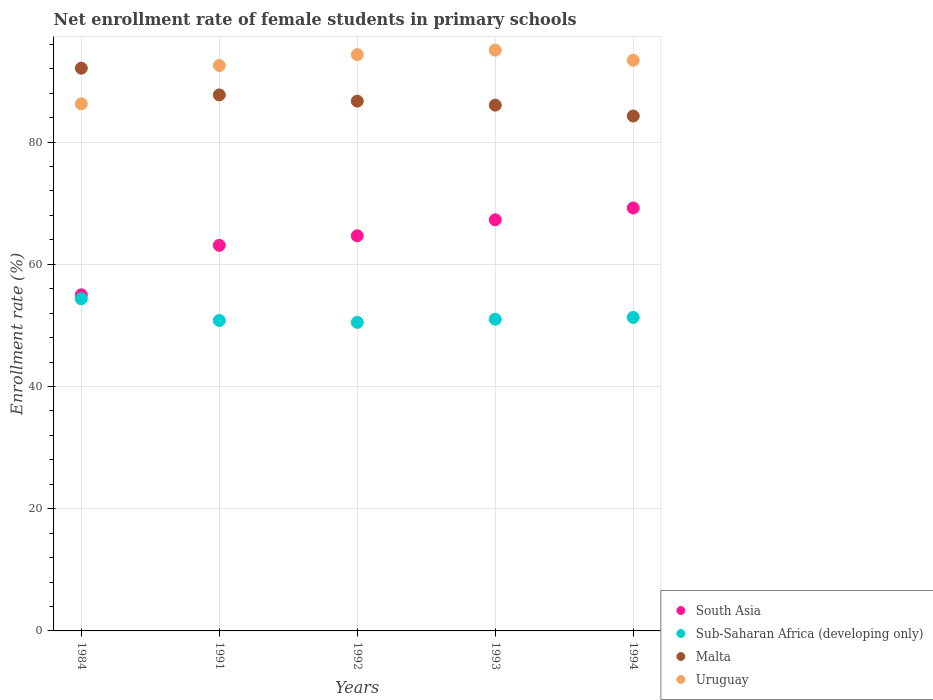Is the number of dotlines equal to the number of legend labels?
Make the answer very short. Yes. What is the net enrollment rate of female students in primary schools in South Asia in 1984?
Your answer should be compact. 55. Across all years, what is the maximum net enrollment rate of female students in primary schools in South Asia?
Offer a very short reply. 69.21. Across all years, what is the minimum net enrollment rate of female students in primary schools in Malta?
Your response must be concise. 84.26. In which year was the net enrollment rate of female students in primary schools in Malta maximum?
Make the answer very short. 1984. In which year was the net enrollment rate of female students in primary schools in South Asia minimum?
Your answer should be compact. 1984. What is the total net enrollment rate of female students in primary schools in Uruguay in the graph?
Provide a short and direct response. 461.5. What is the difference between the net enrollment rate of female students in primary schools in Sub-Saharan Africa (developing only) in 1992 and that in 1994?
Provide a succinct answer. -0.8. What is the difference between the net enrollment rate of female students in primary schools in South Asia in 1993 and the net enrollment rate of female students in primary schools in Uruguay in 1992?
Ensure brevity in your answer.  -27.03. What is the average net enrollment rate of female students in primary schools in Sub-Saharan Africa (developing only) per year?
Provide a short and direct response. 51.59. In the year 1991, what is the difference between the net enrollment rate of female students in primary schools in Malta and net enrollment rate of female students in primary schools in Sub-Saharan Africa (developing only)?
Your answer should be very brief. 36.91. In how many years, is the net enrollment rate of female students in primary schools in Malta greater than 56 %?
Your answer should be very brief. 5. What is the ratio of the net enrollment rate of female students in primary schools in Malta in 1984 to that in 1991?
Your answer should be compact. 1.05. What is the difference between the highest and the second highest net enrollment rate of female students in primary schools in South Asia?
Give a very brief answer. 1.93. What is the difference between the highest and the lowest net enrollment rate of female students in primary schools in Sub-Saharan Africa (developing only)?
Make the answer very short. 3.86. How many dotlines are there?
Ensure brevity in your answer.  4. What is the difference between two consecutive major ticks on the Y-axis?
Make the answer very short. 20. Are the values on the major ticks of Y-axis written in scientific E-notation?
Your response must be concise. No. Does the graph contain any zero values?
Offer a terse response. No. Does the graph contain grids?
Ensure brevity in your answer.  Yes. How many legend labels are there?
Keep it short and to the point. 4. What is the title of the graph?
Ensure brevity in your answer.  Net enrollment rate of female students in primary schools. What is the label or title of the X-axis?
Offer a terse response. Years. What is the label or title of the Y-axis?
Provide a short and direct response. Enrollment rate (%). What is the Enrollment rate (%) in South Asia in 1984?
Make the answer very short. 55. What is the Enrollment rate (%) in Sub-Saharan Africa (developing only) in 1984?
Provide a short and direct response. 54.36. What is the Enrollment rate (%) of Malta in 1984?
Provide a succinct answer. 92.09. What is the Enrollment rate (%) in Uruguay in 1984?
Ensure brevity in your answer.  86.25. What is the Enrollment rate (%) in South Asia in 1991?
Keep it short and to the point. 63.1. What is the Enrollment rate (%) in Sub-Saharan Africa (developing only) in 1991?
Offer a very short reply. 50.8. What is the Enrollment rate (%) in Malta in 1991?
Offer a terse response. 87.71. What is the Enrollment rate (%) of Uruguay in 1991?
Your answer should be very brief. 92.53. What is the Enrollment rate (%) in South Asia in 1992?
Offer a very short reply. 64.66. What is the Enrollment rate (%) of Sub-Saharan Africa (developing only) in 1992?
Provide a succinct answer. 50.5. What is the Enrollment rate (%) of Malta in 1992?
Ensure brevity in your answer.  86.7. What is the Enrollment rate (%) in Uruguay in 1992?
Your response must be concise. 94.31. What is the Enrollment rate (%) in South Asia in 1993?
Your response must be concise. 67.28. What is the Enrollment rate (%) of Sub-Saharan Africa (developing only) in 1993?
Give a very brief answer. 51.01. What is the Enrollment rate (%) of Malta in 1993?
Provide a short and direct response. 86.04. What is the Enrollment rate (%) of Uruguay in 1993?
Give a very brief answer. 95.03. What is the Enrollment rate (%) of South Asia in 1994?
Provide a short and direct response. 69.21. What is the Enrollment rate (%) in Sub-Saharan Africa (developing only) in 1994?
Ensure brevity in your answer.  51.3. What is the Enrollment rate (%) in Malta in 1994?
Provide a succinct answer. 84.26. What is the Enrollment rate (%) in Uruguay in 1994?
Give a very brief answer. 93.38. Across all years, what is the maximum Enrollment rate (%) in South Asia?
Your answer should be compact. 69.21. Across all years, what is the maximum Enrollment rate (%) in Sub-Saharan Africa (developing only)?
Your answer should be compact. 54.36. Across all years, what is the maximum Enrollment rate (%) in Malta?
Your response must be concise. 92.09. Across all years, what is the maximum Enrollment rate (%) in Uruguay?
Your answer should be compact. 95.03. Across all years, what is the minimum Enrollment rate (%) in South Asia?
Offer a terse response. 55. Across all years, what is the minimum Enrollment rate (%) of Sub-Saharan Africa (developing only)?
Offer a terse response. 50.5. Across all years, what is the minimum Enrollment rate (%) of Malta?
Offer a very short reply. 84.26. Across all years, what is the minimum Enrollment rate (%) in Uruguay?
Your response must be concise. 86.25. What is the total Enrollment rate (%) of South Asia in the graph?
Provide a short and direct response. 319.26. What is the total Enrollment rate (%) of Sub-Saharan Africa (developing only) in the graph?
Give a very brief answer. 257.96. What is the total Enrollment rate (%) of Malta in the graph?
Make the answer very short. 436.8. What is the total Enrollment rate (%) in Uruguay in the graph?
Ensure brevity in your answer.  461.5. What is the difference between the Enrollment rate (%) of South Asia in 1984 and that in 1991?
Your response must be concise. -8.09. What is the difference between the Enrollment rate (%) in Sub-Saharan Africa (developing only) in 1984 and that in 1991?
Make the answer very short. 3.55. What is the difference between the Enrollment rate (%) of Malta in 1984 and that in 1991?
Give a very brief answer. 4.38. What is the difference between the Enrollment rate (%) of Uruguay in 1984 and that in 1991?
Provide a short and direct response. -6.27. What is the difference between the Enrollment rate (%) of South Asia in 1984 and that in 1992?
Your answer should be compact. -9.66. What is the difference between the Enrollment rate (%) in Sub-Saharan Africa (developing only) in 1984 and that in 1992?
Your answer should be very brief. 3.86. What is the difference between the Enrollment rate (%) in Malta in 1984 and that in 1992?
Ensure brevity in your answer.  5.39. What is the difference between the Enrollment rate (%) of Uruguay in 1984 and that in 1992?
Offer a very short reply. -8.05. What is the difference between the Enrollment rate (%) in South Asia in 1984 and that in 1993?
Give a very brief answer. -12.28. What is the difference between the Enrollment rate (%) in Sub-Saharan Africa (developing only) in 1984 and that in 1993?
Ensure brevity in your answer.  3.35. What is the difference between the Enrollment rate (%) of Malta in 1984 and that in 1993?
Keep it short and to the point. 6.05. What is the difference between the Enrollment rate (%) of Uruguay in 1984 and that in 1993?
Ensure brevity in your answer.  -8.78. What is the difference between the Enrollment rate (%) in South Asia in 1984 and that in 1994?
Give a very brief answer. -14.21. What is the difference between the Enrollment rate (%) of Sub-Saharan Africa (developing only) in 1984 and that in 1994?
Offer a very short reply. 3.06. What is the difference between the Enrollment rate (%) in Malta in 1984 and that in 1994?
Give a very brief answer. 7.83. What is the difference between the Enrollment rate (%) of Uruguay in 1984 and that in 1994?
Your answer should be very brief. -7.12. What is the difference between the Enrollment rate (%) of South Asia in 1991 and that in 1992?
Provide a short and direct response. -1.57. What is the difference between the Enrollment rate (%) in Sub-Saharan Africa (developing only) in 1991 and that in 1992?
Provide a short and direct response. 0.31. What is the difference between the Enrollment rate (%) of Malta in 1991 and that in 1992?
Offer a very short reply. 1.02. What is the difference between the Enrollment rate (%) of Uruguay in 1991 and that in 1992?
Give a very brief answer. -1.78. What is the difference between the Enrollment rate (%) of South Asia in 1991 and that in 1993?
Offer a very short reply. -4.18. What is the difference between the Enrollment rate (%) of Sub-Saharan Africa (developing only) in 1991 and that in 1993?
Ensure brevity in your answer.  -0.2. What is the difference between the Enrollment rate (%) in Malta in 1991 and that in 1993?
Give a very brief answer. 1.67. What is the difference between the Enrollment rate (%) of Uruguay in 1991 and that in 1993?
Provide a short and direct response. -2.51. What is the difference between the Enrollment rate (%) in South Asia in 1991 and that in 1994?
Your answer should be compact. -6.12. What is the difference between the Enrollment rate (%) of Sub-Saharan Africa (developing only) in 1991 and that in 1994?
Your answer should be very brief. -0.49. What is the difference between the Enrollment rate (%) of Malta in 1991 and that in 1994?
Your response must be concise. 3.45. What is the difference between the Enrollment rate (%) in Uruguay in 1991 and that in 1994?
Keep it short and to the point. -0.85. What is the difference between the Enrollment rate (%) of South Asia in 1992 and that in 1993?
Provide a succinct answer. -2.62. What is the difference between the Enrollment rate (%) in Sub-Saharan Africa (developing only) in 1992 and that in 1993?
Offer a terse response. -0.51. What is the difference between the Enrollment rate (%) in Malta in 1992 and that in 1993?
Your answer should be very brief. 0.66. What is the difference between the Enrollment rate (%) of Uruguay in 1992 and that in 1993?
Offer a very short reply. -0.73. What is the difference between the Enrollment rate (%) in South Asia in 1992 and that in 1994?
Make the answer very short. -4.55. What is the difference between the Enrollment rate (%) in Sub-Saharan Africa (developing only) in 1992 and that in 1994?
Ensure brevity in your answer.  -0.8. What is the difference between the Enrollment rate (%) of Malta in 1992 and that in 1994?
Make the answer very short. 2.44. What is the difference between the Enrollment rate (%) in Uruguay in 1992 and that in 1994?
Ensure brevity in your answer.  0.93. What is the difference between the Enrollment rate (%) in South Asia in 1993 and that in 1994?
Offer a terse response. -1.93. What is the difference between the Enrollment rate (%) in Sub-Saharan Africa (developing only) in 1993 and that in 1994?
Keep it short and to the point. -0.29. What is the difference between the Enrollment rate (%) in Malta in 1993 and that in 1994?
Ensure brevity in your answer.  1.78. What is the difference between the Enrollment rate (%) in Uruguay in 1993 and that in 1994?
Your answer should be compact. 1.66. What is the difference between the Enrollment rate (%) in South Asia in 1984 and the Enrollment rate (%) in Sub-Saharan Africa (developing only) in 1991?
Your response must be concise. 4.2. What is the difference between the Enrollment rate (%) of South Asia in 1984 and the Enrollment rate (%) of Malta in 1991?
Your response must be concise. -32.71. What is the difference between the Enrollment rate (%) in South Asia in 1984 and the Enrollment rate (%) in Uruguay in 1991?
Make the answer very short. -37.52. What is the difference between the Enrollment rate (%) in Sub-Saharan Africa (developing only) in 1984 and the Enrollment rate (%) in Malta in 1991?
Your response must be concise. -33.36. What is the difference between the Enrollment rate (%) of Sub-Saharan Africa (developing only) in 1984 and the Enrollment rate (%) of Uruguay in 1991?
Your response must be concise. -38.17. What is the difference between the Enrollment rate (%) of Malta in 1984 and the Enrollment rate (%) of Uruguay in 1991?
Provide a short and direct response. -0.44. What is the difference between the Enrollment rate (%) in South Asia in 1984 and the Enrollment rate (%) in Sub-Saharan Africa (developing only) in 1992?
Provide a short and direct response. 4.51. What is the difference between the Enrollment rate (%) in South Asia in 1984 and the Enrollment rate (%) in Malta in 1992?
Provide a succinct answer. -31.69. What is the difference between the Enrollment rate (%) in South Asia in 1984 and the Enrollment rate (%) in Uruguay in 1992?
Offer a very short reply. -39.3. What is the difference between the Enrollment rate (%) of Sub-Saharan Africa (developing only) in 1984 and the Enrollment rate (%) of Malta in 1992?
Make the answer very short. -32.34. What is the difference between the Enrollment rate (%) in Sub-Saharan Africa (developing only) in 1984 and the Enrollment rate (%) in Uruguay in 1992?
Ensure brevity in your answer.  -39.95. What is the difference between the Enrollment rate (%) in Malta in 1984 and the Enrollment rate (%) in Uruguay in 1992?
Make the answer very short. -2.22. What is the difference between the Enrollment rate (%) in South Asia in 1984 and the Enrollment rate (%) in Sub-Saharan Africa (developing only) in 1993?
Your answer should be very brief. 4. What is the difference between the Enrollment rate (%) of South Asia in 1984 and the Enrollment rate (%) of Malta in 1993?
Offer a very short reply. -31.04. What is the difference between the Enrollment rate (%) of South Asia in 1984 and the Enrollment rate (%) of Uruguay in 1993?
Your answer should be very brief. -40.03. What is the difference between the Enrollment rate (%) in Sub-Saharan Africa (developing only) in 1984 and the Enrollment rate (%) in Malta in 1993?
Your answer should be compact. -31.69. What is the difference between the Enrollment rate (%) in Sub-Saharan Africa (developing only) in 1984 and the Enrollment rate (%) in Uruguay in 1993?
Give a very brief answer. -40.68. What is the difference between the Enrollment rate (%) in Malta in 1984 and the Enrollment rate (%) in Uruguay in 1993?
Make the answer very short. -2.94. What is the difference between the Enrollment rate (%) in South Asia in 1984 and the Enrollment rate (%) in Sub-Saharan Africa (developing only) in 1994?
Provide a succinct answer. 3.7. What is the difference between the Enrollment rate (%) of South Asia in 1984 and the Enrollment rate (%) of Malta in 1994?
Offer a very short reply. -29.26. What is the difference between the Enrollment rate (%) of South Asia in 1984 and the Enrollment rate (%) of Uruguay in 1994?
Ensure brevity in your answer.  -38.37. What is the difference between the Enrollment rate (%) of Sub-Saharan Africa (developing only) in 1984 and the Enrollment rate (%) of Malta in 1994?
Keep it short and to the point. -29.9. What is the difference between the Enrollment rate (%) in Sub-Saharan Africa (developing only) in 1984 and the Enrollment rate (%) in Uruguay in 1994?
Provide a succinct answer. -39.02. What is the difference between the Enrollment rate (%) in Malta in 1984 and the Enrollment rate (%) in Uruguay in 1994?
Provide a short and direct response. -1.29. What is the difference between the Enrollment rate (%) in South Asia in 1991 and the Enrollment rate (%) in Sub-Saharan Africa (developing only) in 1992?
Provide a succinct answer. 12.6. What is the difference between the Enrollment rate (%) of South Asia in 1991 and the Enrollment rate (%) of Malta in 1992?
Offer a very short reply. -23.6. What is the difference between the Enrollment rate (%) of South Asia in 1991 and the Enrollment rate (%) of Uruguay in 1992?
Provide a short and direct response. -31.21. What is the difference between the Enrollment rate (%) of Sub-Saharan Africa (developing only) in 1991 and the Enrollment rate (%) of Malta in 1992?
Offer a very short reply. -35.89. What is the difference between the Enrollment rate (%) in Sub-Saharan Africa (developing only) in 1991 and the Enrollment rate (%) in Uruguay in 1992?
Keep it short and to the point. -43.5. What is the difference between the Enrollment rate (%) of Malta in 1991 and the Enrollment rate (%) of Uruguay in 1992?
Your answer should be compact. -6.6. What is the difference between the Enrollment rate (%) in South Asia in 1991 and the Enrollment rate (%) in Sub-Saharan Africa (developing only) in 1993?
Make the answer very short. 12.09. What is the difference between the Enrollment rate (%) of South Asia in 1991 and the Enrollment rate (%) of Malta in 1993?
Provide a short and direct response. -22.94. What is the difference between the Enrollment rate (%) in South Asia in 1991 and the Enrollment rate (%) in Uruguay in 1993?
Your answer should be compact. -31.94. What is the difference between the Enrollment rate (%) of Sub-Saharan Africa (developing only) in 1991 and the Enrollment rate (%) of Malta in 1993?
Provide a succinct answer. -35.24. What is the difference between the Enrollment rate (%) of Sub-Saharan Africa (developing only) in 1991 and the Enrollment rate (%) of Uruguay in 1993?
Your answer should be very brief. -44.23. What is the difference between the Enrollment rate (%) of Malta in 1991 and the Enrollment rate (%) of Uruguay in 1993?
Your answer should be very brief. -7.32. What is the difference between the Enrollment rate (%) of South Asia in 1991 and the Enrollment rate (%) of Sub-Saharan Africa (developing only) in 1994?
Provide a short and direct response. 11.8. What is the difference between the Enrollment rate (%) of South Asia in 1991 and the Enrollment rate (%) of Malta in 1994?
Your response must be concise. -21.16. What is the difference between the Enrollment rate (%) of South Asia in 1991 and the Enrollment rate (%) of Uruguay in 1994?
Your answer should be very brief. -30.28. What is the difference between the Enrollment rate (%) in Sub-Saharan Africa (developing only) in 1991 and the Enrollment rate (%) in Malta in 1994?
Keep it short and to the point. -33.46. What is the difference between the Enrollment rate (%) of Sub-Saharan Africa (developing only) in 1991 and the Enrollment rate (%) of Uruguay in 1994?
Keep it short and to the point. -42.57. What is the difference between the Enrollment rate (%) in Malta in 1991 and the Enrollment rate (%) in Uruguay in 1994?
Keep it short and to the point. -5.67. What is the difference between the Enrollment rate (%) of South Asia in 1992 and the Enrollment rate (%) of Sub-Saharan Africa (developing only) in 1993?
Your answer should be very brief. 13.66. What is the difference between the Enrollment rate (%) in South Asia in 1992 and the Enrollment rate (%) in Malta in 1993?
Offer a very short reply. -21.38. What is the difference between the Enrollment rate (%) in South Asia in 1992 and the Enrollment rate (%) in Uruguay in 1993?
Offer a very short reply. -30.37. What is the difference between the Enrollment rate (%) of Sub-Saharan Africa (developing only) in 1992 and the Enrollment rate (%) of Malta in 1993?
Your response must be concise. -35.55. What is the difference between the Enrollment rate (%) of Sub-Saharan Africa (developing only) in 1992 and the Enrollment rate (%) of Uruguay in 1993?
Your answer should be compact. -44.54. What is the difference between the Enrollment rate (%) in Malta in 1992 and the Enrollment rate (%) in Uruguay in 1993?
Keep it short and to the point. -8.34. What is the difference between the Enrollment rate (%) in South Asia in 1992 and the Enrollment rate (%) in Sub-Saharan Africa (developing only) in 1994?
Make the answer very short. 13.36. What is the difference between the Enrollment rate (%) in South Asia in 1992 and the Enrollment rate (%) in Malta in 1994?
Offer a very short reply. -19.6. What is the difference between the Enrollment rate (%) in South Asia in 1992 and the Enrollment rate (%) in Uruguay in 1994?
Offer a very short reply. -28.71. What is the difference between the Enrollment rate (%) in Sub-Saharan Africa (developing only) in 1992 and the Enrollment rate (%) in Malta in 1994?
Your answer should be compact. -33.76. What is the difference between the Enrollment rate (%) in Sub-Saharan Africa (developing only) in 1992 and the Enrollment rate (%) in Uruguay in 1994?
Provide a short and direct response. -42.88. What is the difference between the Enrollment rate (%) in Malta in 1992 and the Enrollment rate (%) in Uruguay in 1994?
Make the answer very short. -6.68. What is the difference between the Enrollment rate (%) of South Asia in 1993 and the Enrollment rate (%) of Sub-Saharan Africa (developing only) in 1994?
Your answer should be very brief. 15.98. What is the difference between the Enrollment rate (%) of South Asia in 1993 and the Enrollment rate (%) of Malta in 1994?
Offer a terse response. -16.98. What is the difference between the Enrollment rate (%) in South Asia in 1993 and the Enrollment rate (%) in Uruguay in 1994?
Give a very brief answer. -26.1. What is the difference between the Enrollment rate (%) of Sub-Saharan Africa (developing only) in 1993 and the Enrollment rate (%) of Malta in 1994?
Offer a very short reply. -33.25. What is the difference between the Enrollment rate (%) of Sub-Saharan Africa (developing only) in 1993 and the Enrollment rate (%) of Uruguay in 1994?
Offer a very short reply. -42.37. What is the difference between the Enrollment rate (%) in Malta in 1993 and the Enrollment rate (%) in Uruguay in 1994?
Give a very brief answer. -7.34. What is the average Enrollment rate (%) in South Asia per year?
Provide a short and direct response. 63.85. What is the average Enrollment rate (%) of Sub-Saharan Africa (developing only) per year?
Offer a very short reply. 51.59. What is the average Enrollment rate (%) of Malta per year?
Offer a very short reply. 87.36. What is the average Enrollment rate (%) of Uruguay per year?
Provide a short and direct response. 92.3. In the year 1984, what is the difference between the Enrollment rate (%) in South Asia and Enrollment rate (%) in Sub-Saharan Africa (developing only)?
Provide a short and direct response. 0.65. In the year 1984, what is the difference between the Enrollment rate (%) in South Asia and Enrollment rate (%) in Malta?
Ensure brevity in your answer.  -37.09. In the year 1984, what is the difference between the Enrollment rate (%) in South Asia and Enrollment rate (%) in Uruguay?
Provide a short and direct response. -31.25. In the year 1984, what is the difference between the Enrollment rate (%) of Sub-Saharan Africa (developing only) and Enrollment rate (%) of Malta?
Keep it short and to the point. -37.74. In the year 1984, what is the difference between the Enrollment rate (%) of Sub-Saharan Africa (developing only) and Enrollment rate (%) of Uruguay?
Ensure brevity in your answer.  -31.9. In the year 1984, what is the difference between the Enrollment rate (%) in Malta and Enrollment rate (%) in Uruguay?
Provide a succinct answer. 5.84. In the year 1991, what is the difference between the Enrollment rate (%) in South Asia and Enrollment rate (%) in Sub-Saharan Africa (developing only)?
Make the answer very short. 12.29. In the year 1991, what is the difference between the Enrollment rate (%) of South Asia and Enrollment rate (%) of Malta?
Give a very brief answer. -24.61. In the year 1991, what is the difference between the Enrollment rate (%) of South Asia and Enrollment rate (%) of Uruguay?
Make the answer very short. -29.43. In the year 1991, what is the difference between the Enrollment rate (%) of Sub-Saharan Africa (developing only) and Enrollment rate (%) of Malta?
Provide a succinct answer. -36.91. In the year 1991, what is the difference between the Enrollment rate (%) in Sub-Saharan Africa (developing only) and Enrollment rate (%) in Uruguay?
Your response must be concise. -41.72. In the year 1991, what is the difference between the Enrollment rate (%) of Malta and Enrollment rate (%) of Uruguay?
Ensure brevity in your answer.  -4.82. In the year 1992, what is the difference between the Enrollment rate (%) in South Asia and Enrollment rate (%) in Sub-Saharan Africa (developing only)?
Give a very brief answer. 14.17. In the year 1992, what is the difference between the Enrollment rate (%) of South Asia and Enrollment rate (%) of Malta?
Your answer should be very brief. -22.03. In the year 1992, what is the difference between the Enrollment rate (%) of South Asia and Enrollment rate (%) of Uruguay?
Your response must be concise. -29.64. In the year 1992, what is the difference between the Enrollment rate (%) of Sub-Saharan Africa (developing only) and Enrollment rate (%) of Malta?
Your answer should be compact. -36.2. In the year 1992, what is the difference between the Enrollment rate (%) of Sub-Saharan Africa (developing only) and Enrollment rate (%) of Uruguay?
Keep it short and to the point. -43.81. In the year 1992, what is the difference between the Enrollment rate (%) in Malta and Enrollment rate (%) in Uruguay?
Give a very brief answer. -7.61. In the year 1993, what is the difference between the Enrollment rate (%) of South Asia and Enrollment rate (%) of Sub-Saharan Africa (developing only)?
Make the answer very short. 16.27. In the year 1993, what is the difference between the Enrollment rate (%) in South Asia and Enrollment rate (%) in Malta?
Provide a succinct answer. -18.76. In the year 1993, what is the difference between the Enrollment rate (%) in South Asia and Enrollment rate (%) in Uruguay?
Your answer should be compact. -27.75. In the year 1993, what is the difference between the Enrollment rate (%) in Sub-Saharan Africa (developing only) and Enrollment rate (%) in Malta?
Offer a very short reply. -35.03. In the year 1993, what is the difference between the Enrollment rate (%) of Sub-Saharan Africa (developing only) and Enrollment rate (%) of Uruguay?
Give a very brief answer. -44.03. In the year 1993, what is the difference between the Enrollment rate (%) in Malta and Enrollment rate (%) in Uruguay?
Your answer should be very brief. -8.99. In the year 1994, what is the difference between the Enrollment rate (%) of South Asia and Enrollment rate (%) of Sub-Saharan Africa (developing only)?
Keep it short and to the point. 17.91. In the year 1994, what is the difference between the Enrollment rate (%) of South Asia and Enrollment rate (%) of Malta?
Provide a succinct answer. -15.05. In the year 1994, what is the difference between the Enrollment rate (%) of South Asia and Enrollment rate (%) of Uruguay?
Your answer should be very brief. -24.16. In the year 1994, what is the difference between the Enrollment rate (%) of Sub-Saharan Africa (developing only) and Enrollment rate (%) of Malta?
Give a very brief answer. -32.96. In the year 1994, what is the difference between the Enrollment rate (%) in Sub-Saharan Africa (developing only) and Enrollment rate (%) in Uruguay?
Your answer should be compact. -42.08. In the year 1994, what is the difference between the Enrollment rate (%) of Malta and Enrollment rate (%) of Uruguay?
Your response must be concise. -9.12. What is the ratio of the Enrollment rate (%) in South Asia in 1984 to that in 1991?
Your answer should be compact. 0.87. What is the ratio of the Enrollment rate (%) of Sub-Saharan Africa (developing only) in 1984 to that in 1991?
Your answer should be compact. 1.07. What is the ratio of the Enrollment rate (%) of Malta in 1984 to that in 1991?
Offer a very short reply. 1.05. What is the ratio of the Enrollment rate (%) in Uruguay in 1984 to that in 1991?
Keep it short and to the point. 0.93. What is the ratio of the Enrollment rate (%) of South Asia in 1984 to that in 1992?
Your response must be concise. 0.85. What is the ratio of the Enrollment rate (%) in Sub-Saharan Africa (developing only) in 1984 to that in 1992?
Offer a terse response. 1.08. What is the ratio of the Enrollment rate (%) of Malta in 1984 to that in 1992?
Provide a short and direct response. 1.06. What is the ratio of the Enrollment rate (%) in Uruguay in 1984 to that in 1992?
Make the answer very short. 0.91. What is the ratio of the Enrollment rate (%) of South Asia in 1984 to that in 1993?
Your answer should be very brief. 0.82. What is the ratio of the Enrollment rate (%) of Sub-Saharan Africa (developing only) in 1984 to that in 1993?
Make the answer very short. 1.07. What is the ratio of the Enrollment rate (%) of Malta in 1984 to that in 1993?
Ensure brevity in your answer.  1.07. What is the ratio of the Enrollment rate (%) in Uruguay in 1984 to that in 1993?
Ensure brevity in your answer.  0.91. What is the ratio of the Enrollment rate (%) in South Asia in 1984 to that in 1994?
Keep it short and to the point. 0.79. What is the ratio of the Enrollment rate (%) in Sub-Saharan Africa (developing only) in 1984 to that in 1994?
Provide a short and direct response. 1.06. What is the ratio of the Enrollment rate (%) of Malta in 1984 to that in 1994?
Give a very brief answer. 1.09. What is the ratio of the Enrollment rate (%) in Uruguay in 1984 to that in 1994?
Your answer should be compact. 0.92. What is the ratio of the Enrollment rate (%) of South Asia in 1991 to that in 1992?
Make the answer very short. 0.98. What is the ratio of the Enrollment rate (%) of Malta in 1991 to that in 1992?
Provide a succinct answer. 1.01. What is the ratio of the Enrollment rate (%) of Uruguay in 1991 to that in 1992?
Provide a short and direct response. 0.98. What is the ratio of the Enrollment rate (%) in South Asia in 1991 to that in 1993?
Provide a short and direct response. 0.94. What is the ratio of the Enrollment rate (%) in Malta in 1991 to that in 1993?
Your answer should be compact. 1.02. What is the ratio of the Enrollment rate (%) in Uruguay in 1991 to that in 1993?
Keep it short and to the point. 0.97. What is the ratio of the Enrollment rate (%) of South Asia in 1991 to that in 1994?
Offer a very short reply. 0.91. What is the ratio of the Enrollment rate (%) of Malta in 1991 to that in 1994?
Give a very brief answer. 1.04. What is the ratio of the Enrollment rate (%) of Uruguay in 1991 to that in 1994?
Offer a very short reply. 0.99. What is the ratio of the Enrollment rate (%) in South Asia in 1992 to that in 1993?
Your response must be concise. 0.96. What is the ratio of the Enrollment rate (%) of Malta in 1992 to that in 1993?
Provide a succinct answer. 1.01. What is the ratio of the Enrollment rate (%) of South Asia in 1992 to that in 1994?
Provide a succinct answer. 0.93. What is the ratio of the Enrollment rate (%) in Sub-Saharan Africa (developing only) in 1992 to that in 1994?
Provide a short and direct response. 0.98. What is the ratio of the Enrollment rate (%) in Malta in 1992 to that in 1994?
Make the answer very short. 1.03. What is the ratio of the Enrollment rate (%) in Uruguay in 1992 to that in 1994?
Make the answer very short. 1.01. What is the ratio of the Enrollment rate (%) in South Asia in 1993 to that in 1994?
Keep it short and to the point. 0.97. What is the ratio of the Enrollment rate (%) in Sub-Saharan Africa (developing only) in 1993 to that in 1994?
Keep it short and to the point. 0.99. What is the ratio of the Enrollment rate (%) in Malta in 1993 to that in 1994?
Ensure brevity in your answer.  1.02. What is the ratio of the Enrollment rate (%) in Uruguay in 1993 to that in 1994?
Offer a very short reply. 1.02. What is the difference between the highest and the second highest Enrollment rate (%) of South Asia?
Provide a short and direct response. 1.93. What is the difference between the highest and the second highest Enrollment rate (%) of Sub-Saharan Africa (developing only)?
Give a very brief answer. 3.06. What is the difference between the highest and the second highest Enrollment rate (%) in Malta?
Provide a short and direct response. 4.38. What is the difference between the highest and the second highest Enrollment rate (%) of Uruguay?
Offer a terse response. 0.73. What is the difference between the highest and the lowest Enrollment rate (%) of South Asia?
Keep it short and to the point. 14.21. What is the difference between the highest and the lowest Enrollment rate (%) in Sub-Saharan Africa (developing only)?
Your answer should be compact. 3.86. What is the difference between the highest and the lowest Enrollment rate (%) in Malta?
Provide a short and direct response. 7.83. What is the difference between the highest and the lowest Enrollment rate (%) in Uruguay?
Give a very brief answer. 8.78. 